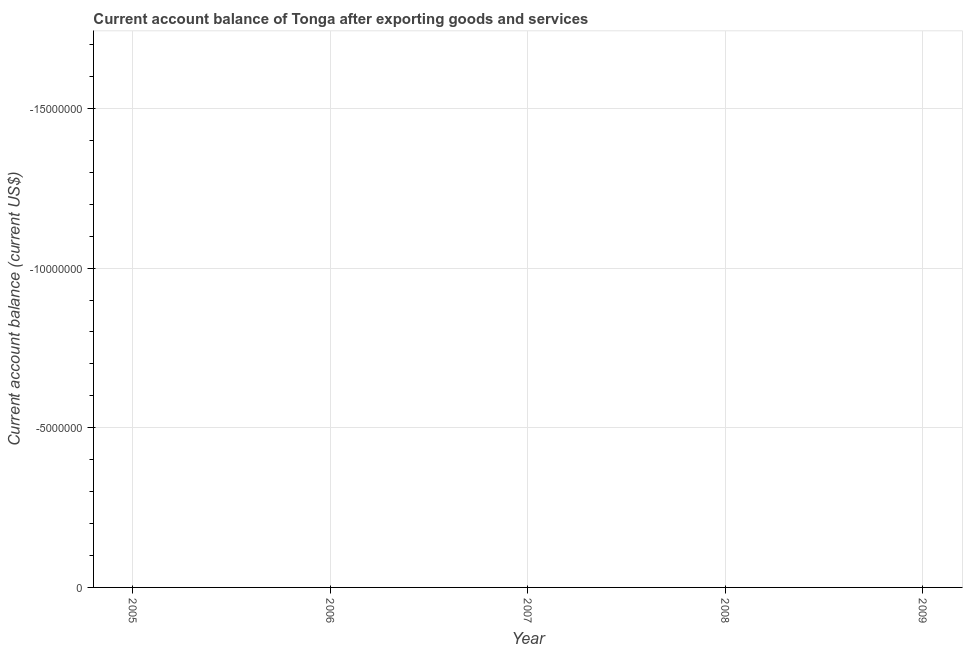Across all years, what is the minimum current account balance?
Offer a terse response. 0. What is the average current account balance per year?
Give a very brief answer. 0. In how many years, is the current account balance greater than -7000000 US$?
Offer a very short reply. 0. In how many years, is the current account balance greater than the average current account balance taken over all years?
Your response must be concise. 0. How many years are there in the graph?
Offer a terse response. 5. What is the difference between two consecutive major ticks on the Y-axis?
Provide a short and direct response. 5.00e+06. Are the values on the major ticks of Y-axis written in scientific E-notation?
Your answer should be compact. No. Does the graph contain grids?
Keep it short and to the point. Yes. What is the title of the graph?
Your response must be concise. Current account balance of Tonga after exporting goods and services. What is the label or title of the X-axis?
Your answer should be very brief. Year. What is the label or title of the Y-axis?
Provide a succinct answer. Current account balance (current US$). What is the Current account balance (current US$) in 2008?
Your response must be concise. 0. 